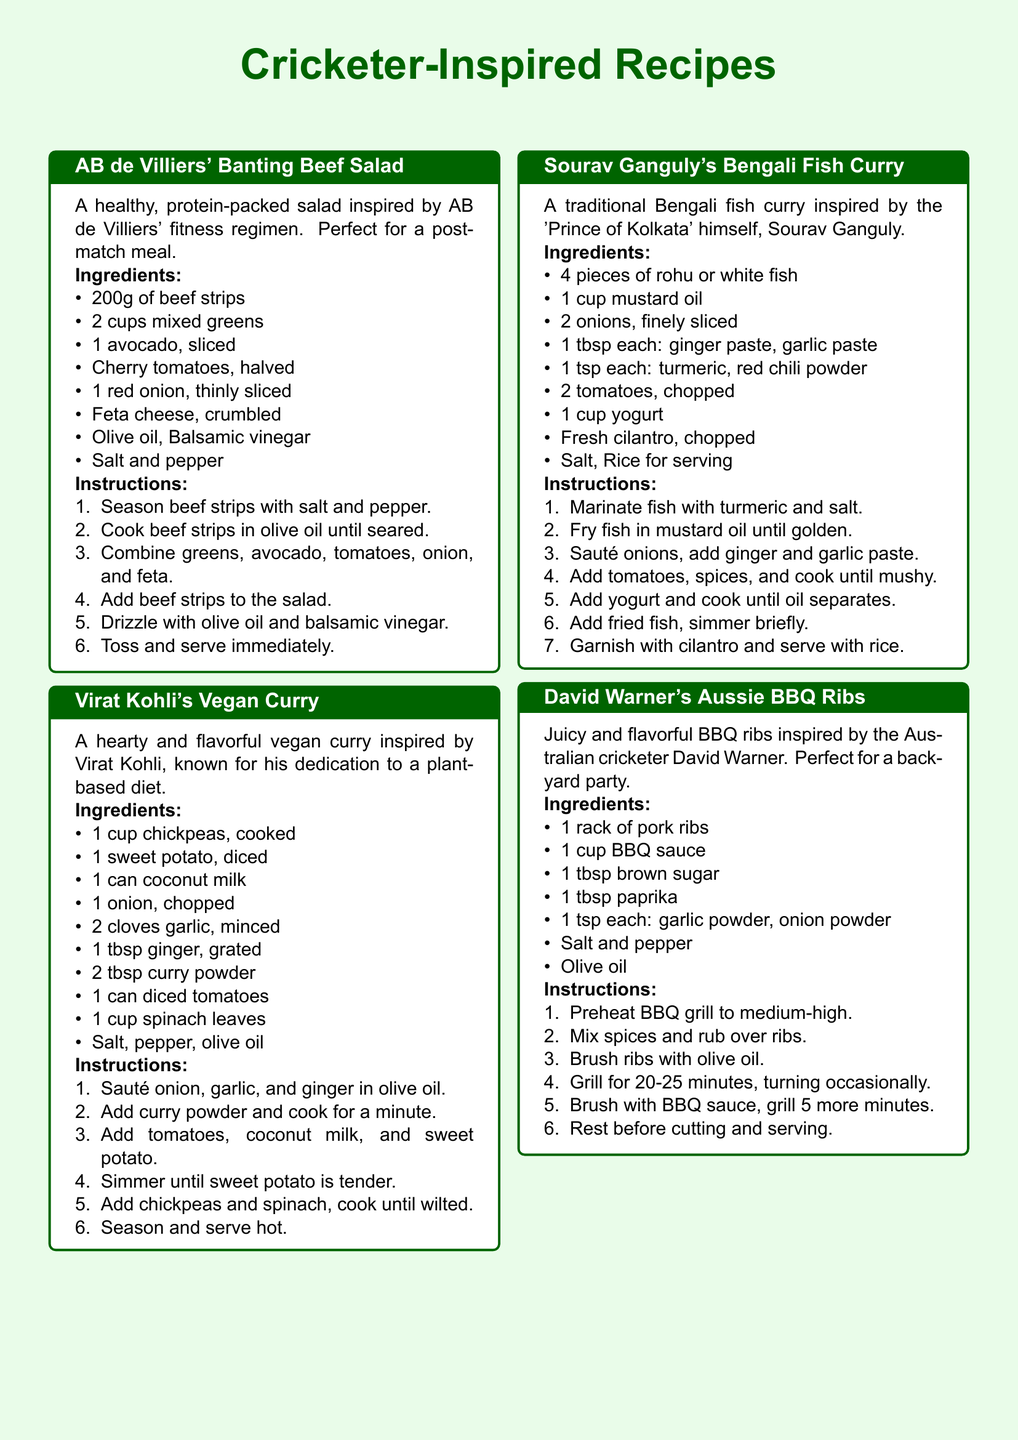What is the first recipe listed? The first recipe is titled "AB de Villiers' Banting Beef Salad," which appears at the top of the document.
Answer: AB de Villiers' Banting Beef Salad How many cups of mixed greens are used in AB de Villiers' recipe? The recipe specifies 2 cups of mixed greens as an ingredient.
Answer: 2 cups What type of cuisine is Sourav Ganguly's dish? The dish is identified as a traditional Bengali fish curry, indicating its cuisine type.
Answer: Bengali What is the main protein source in David Warner's recipe? The recipe mentions '1 rack of pork ribs' as the primary ingredient, indicating the protein source.
Answer: Pork ribs How many tablespoons of curry powder are used in Virat Kohli's recipe? The recipe specifies the use of 2 tablespoons of curry powder in the ingredients.
Answer: 2 tbsp What is the total number of ingredients listed for the vegan curry? A count of the ingredients listed for the dish indicates there are 9 items in total.
Answer: 9 What ingredient is common in both AB de Villiers' and David Warner's recipes? Both recipes include olive oil, which is mentioned in their respective ingredient lists.
Answer: Olive oil What ingredient is used as a base for the sauce in David Warner's recipe? The recipe indicates that BBQ sauce is used as the base for the sauce.
Answer: BBQ sauce What is the cooking method used for the fish in Sourav Ganguly's dish? The cooking method specified is frying, as mentioned in the instructions of the recipe.
Answer: Frying 